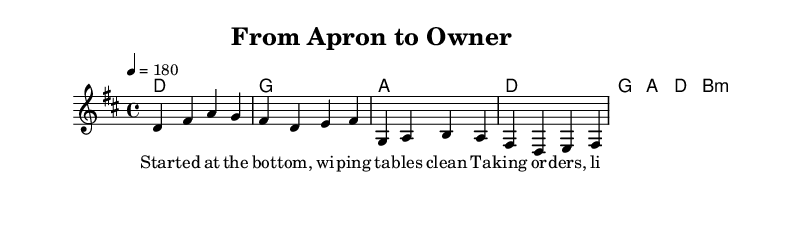What is the key signature of this music? The key signature is D major, which has two sharps (F# and C#). This can be identified from the key signature notation at the beginning of the staff.
Answer: D major What is the time signature of this music? The time signature is 4/4, which indicates four beats in a measure and a quarter note gets one beat. This is visible in the notation at the beginning of the sheet music.
Answer: 4/4 What is the tempo marking for this piece? The tempo marking indicates a speed of 180 beats per minute, as noted in the sheet music. It's described with "4 = 180," meaning there are 180 quarter note beats per minute.
Answer: 180 How many measures are in the verse? The verse contains four measures, as each segment of the melody and chords corresponds to a distinct measure. Counting the vertical lines indicates the boundary of each measure.
Answer: Four What musical genres influence the song's themes? The song reflects influences of punk music, which is characterized by its rebellious themes and emphasis on social issues. The lyrics focus on empowerment and breaking class barriers, common in punk anthems.
Answer: Punk Which line contains the lyrics of the chorus? The chorus lyrics start with "From apron to owner," located after the verse lyrics in the sheet music. It signifies a thematic shift to empowerment and resilience.
Answer: From apron to owner 